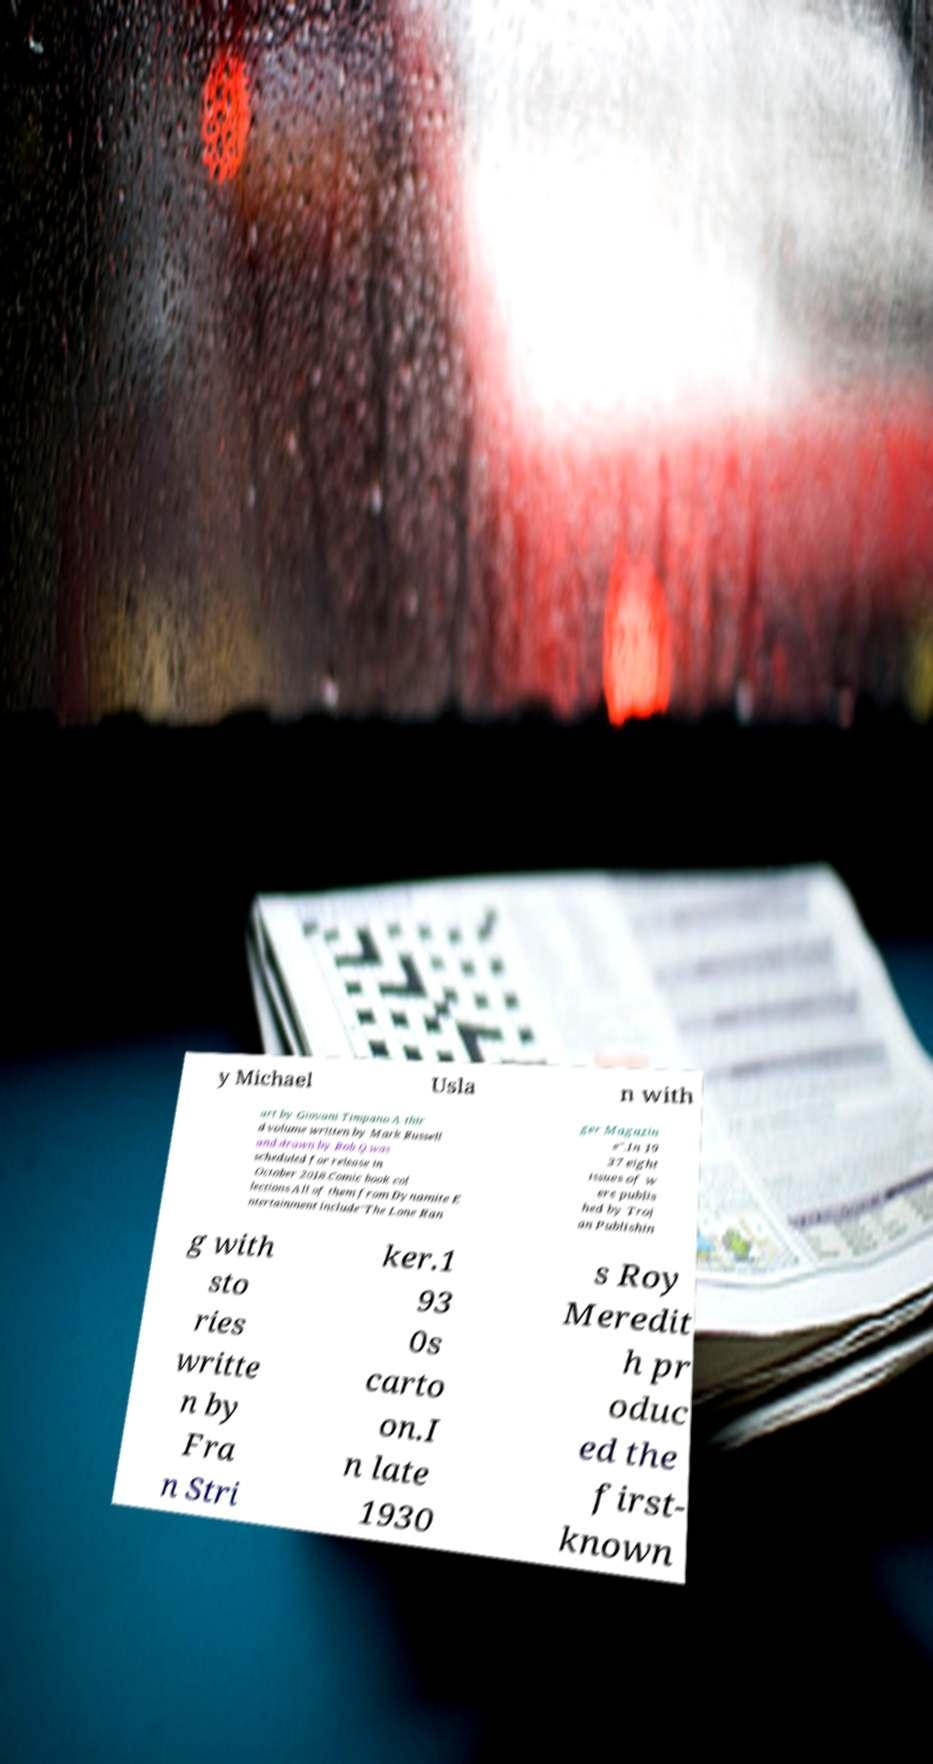Could you extract and type out the text from this image? y Michael Usla n with art by Giovani Timpano.A thir d volume written by Mark Russell and drawn by Bob Q was scheduled for release in October 2018.Comic book col lections.All of them from Dynamite E ntertainment include"The Lone Ran ger Magazin e".In 19 37 eight issues of w ere publis hed by Troj an Publishin g with sto ries writte n by Fra n Stri ker.1 93 0s carto on.I n late 1930 s Roy Meredit h pr oduc ed the first- known 